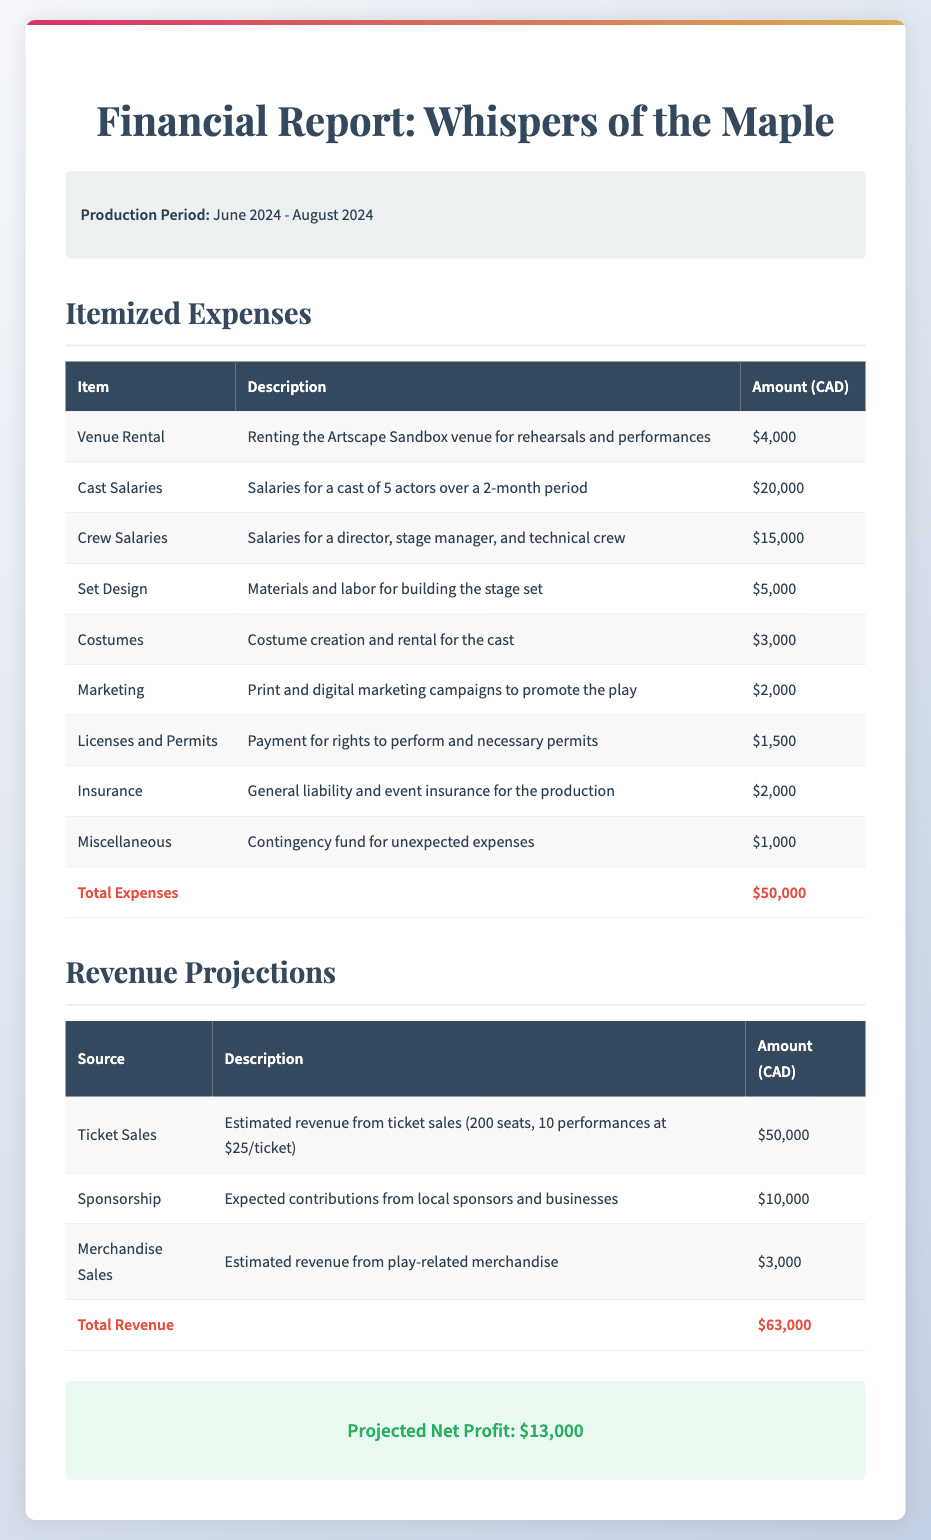What is the production period for the play? The production period is stated in the document as the duration from June 2024 to August 2024.
Answer: June 2024 - August 2024 What is the total amount for cast salaries? The document lists cast salaries as $20,000 for five actors over a two-month period.
Answer: $20,000 How much is allocated for marketing? The marketing expenses are explicitly mentioned in the document as $2,000.
Answer: $2,000 What is the total projected net profit? The projected net profit is derived from the total revenue minus total expenses, which is mentioned clearly in the document.
Answer: $13,000 What is the expected revenue from ticket sales? The revenue from ticket sales is broken down in the document as $50,000 from 200 seats over 10 performances at $25 each.
Answer: $50,000 What is the total amount for venue rental? The document specifies the venue rental cost as $4,000.
Answer: $4,000 How much revenue is projected from merchandise sales? The expected revenue from merchandise sales is directly stated in the document as $3,000.
Answer: $3,000 What are licenses and permits expenses? The licenses and permits expenses are detailed in the document as $1,500 for performance rights and necessary permits.
Answer: $1,500 